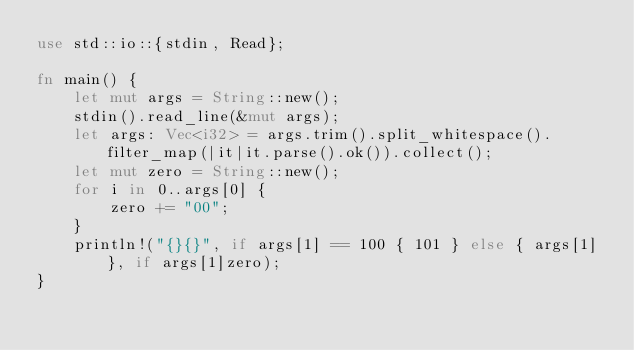<code> <loc_0><loc_0><loc_500><loc_500><_Rust_>use std::io::{stdin, Read};
  
fn main() {
    let mut args = String::new();
    stdin().read_line(&mut args);
    let args: Vec<i32> = args.trim().split_whitespace().filter_map(|it|it.parse().ok()).collect();
    let mut zero = String::new();
    for i in 0..args[0] {
        zero += "00";
    }
    println!("{}{}", if args[1] == 100 { 101 } else { args[1] }, if args[1]zero);
}
</code> 